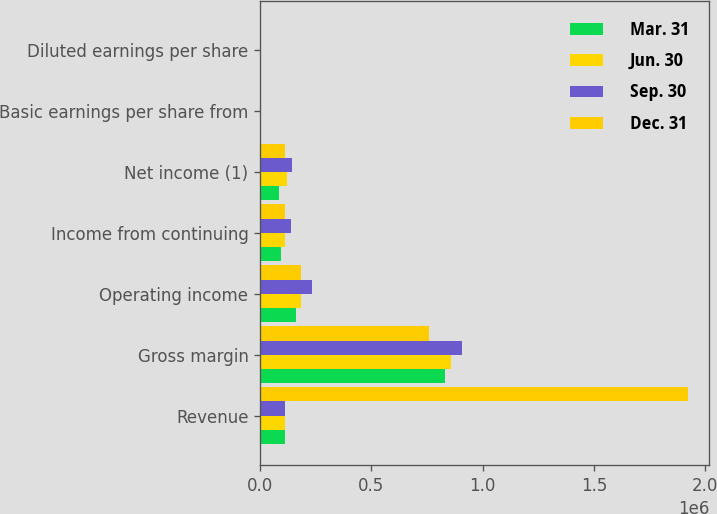Convert chart. <chart><loc_0><loc_0><loc_500><loc_500><stacked_bar_chart><ecel><fcel>Revenue<fcel>Gross margin<fcel>Operating income<fcel>Income from continuing<fcel>Net income (1)<fcel>Basic earnings per share from<fcel>Diluted earnings per share<nl><fcel>Mar. 31<fcel>112171<fcel>830006<fcel>161880<fcel>96298<fcel>86331<fcel>0.31<fcel>0.31<nl><fcel>Jun. 30<fcel>112171<fcel>855444<fcel>183401<fcel>109844<fcel>122688<fcel>0.36<fcel>0.35<nl><fcel>Sep. 30<fcel>112171<fcel>905816<fcel>232445<fcel>137810<fcel>142785<fcel>0.45<fcel>0.45<nl><fcel>Dec. 31<fcel>1.92148e+06<fcel>760437<fcel>185672<fcel>112171<fcel>112171<fcel>0.37<fcel>0.36<nl></chart> 